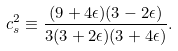<formula> <loc_0><loc_0><loc_500><loc_500>c _ { s } ^ { 2 } \equiv \frac { ( 9 + 4 \epsilon ) ( 3 - 2 \epsilon ) } { 3 ( 3 + 2 \epsilon ) ( 3 + 4 \epsilon ) } .</formula> 